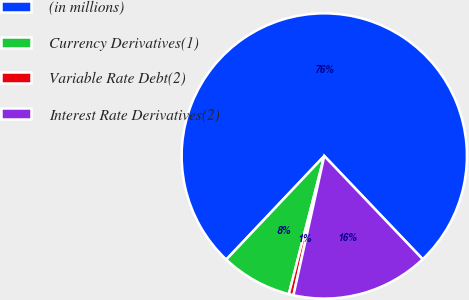Convert chart to OTSL. <chart><loc_0><loc_0><loc_500><loc_500><pie_chart><fcel>(in millions)<fcel>Currency Derivatives(1)<fcel>Variable Rate Debt(2)<fcel>Interest Rate Derivatives(2)<nl><fcel>75.83%<fcel>8.06%<fcel>0.53%<fcel>15.59%<nl></chart> 